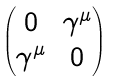Convert formula to latex. <formula><loc_0><loc_0><loc_500><loc_500>\begin{pmatrix} 0 & \gamma ^ { \mu } \\ \gamma ^ { \mu } & 0 \\ \end{pmatrix}</formula> 